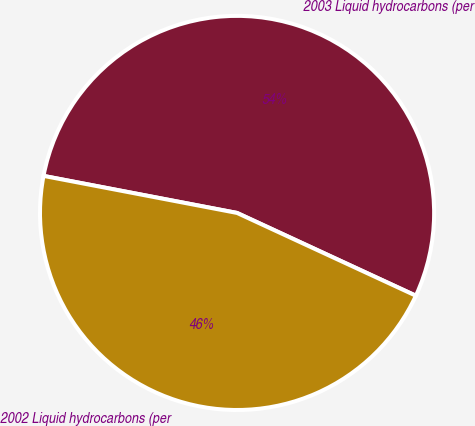Convert chart to OTSL. <chart><loc_0><loc_0><loc_500><loc_500><pie_chart><fcel>2003 Liquid hydrocarbons (per<fcel>2002 Liquid hydrocarbons (per<nl><fcel>53.89%<fcel>46.11%<nl></chart> 